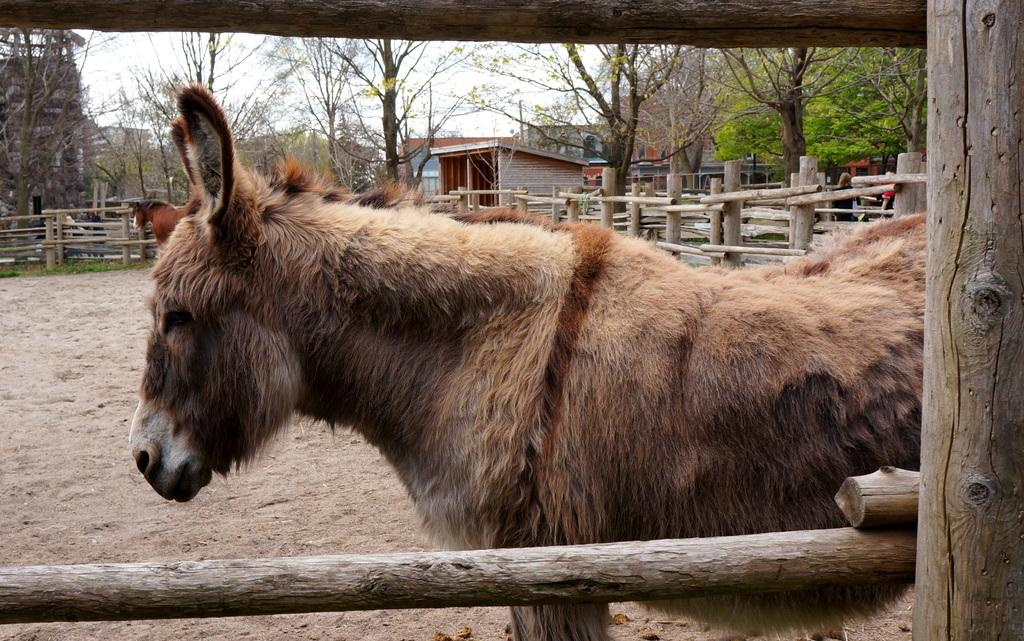What animal is present in the image? There is a donkey in the image. Where is the donkey located? The donkey is in a wooden fence. What can be seen behind the fence in the image? There are trees and buildings behind the fence in the image. What type of scarf is the donkey wearing in the image? There is no scarf present in the image; the donkey is not wearing any clothing. 